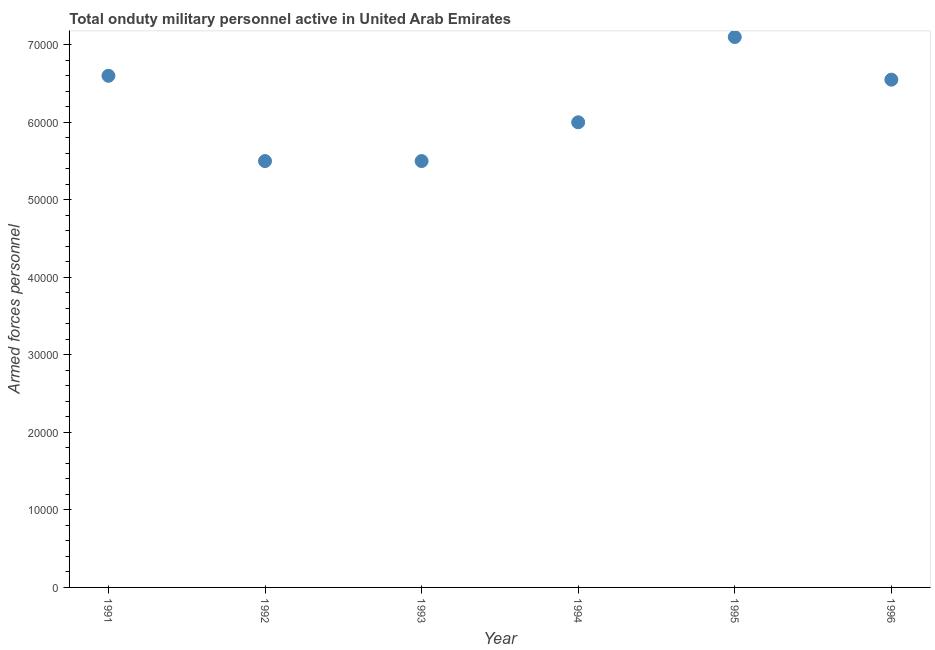What is the number of armed forces personnel in 1993?
Your response must be concise. 5.50e+04. Across all years, what is the maximum number of armed forces personnel?
Keep it short and to the point. 7.10e+04. Across all years, what is the minimum number of armed forces personnel?
Give a very brief answer. 5.50e+04. In which year was the number of armed forces personnel maximum?
Your answer should be very brief. 1995. What is the sum of the number of armed forces personnel?
Give a very brief answer. 3.72e+05. What is the difference between the number of armed forces personnel in 1993 and 1996?
Ensure brevity in your answer.  -1.05e+04. What is the average number of armed forces personnel per year?
Your answer should be very brief. 6.21e+04. What is the median number of armed forces personnel?
Provide a short and direct response. 6.28e+04. Do a majority of the years between 1993 and 1994 (inclusive) have number of armed forces personnel greater than 32000 ?
Provide a succinct answer. Yes. What is the ratio of the number of armed forces personnel in 1993 to that in 1996?
Offer a very short reply. 0.84. Is the difference between the number of armed forces personnel in 1993 and 1995 greater than the difference between any two years?
Offer a terse response. Yes. What is the difference between the highest and the second highest number of armed forces personnel?
Provide a short and direct response. 5000. What is the difference between the highest and the lowest number of armed forces personnel?
Your answer should be compact. 1.60e+04. How many dotlines are there?
Offer a terse response. 1. How many years are there in the graph?
Your answer should be compact. 6. Does the graph contain any zero values?
Make the answer very short. No. What is the title of the graph?
Provide a short and direct response. Total onduty military personnel active in United Arab Emirates. What is the label or title of the X-axis?
Your answer should be very brief. Year. What is the label or title of the Y-axis?
Offer a very short reply. Armed forces personnel. What is the Armed forces personnel in 1991?
Ensure brevity in your answer.  6.60e+04. What is the Armed forces personnel in 1992?
Your answer should be very brief. 5.50e+04. What is the Armed forces personnel in 1993?
Ensure brevity in your answer.  5.50e+04. What is the Armed forces personnel in 1994?
Your answer should be compact. 6.00e+04. What is the Armed forces personnel in 1995?
Make the answer very short. 7.10e+04. What is the Armed forces personnel in 1996?
Offer a terse response. 6.55e+04. What is the difference between the Armed forces personnel in 1991 and 1992?
Ensure brevity in your answer.  1.10e+04. What is the difference between the Armed forces personnel in 1991 and 1993?
Your response must be concise. 1.10e+04. What is the difference between the Armed forces personnel in 1991 and 1994?
Give a very brief answer. 6000. What is the difference between the Armed forces personnel in 1991 and 1995?
Your answer should be compact. -5000. What is the difference between the Armed forces personnel in 1992 and 1994?
Your answer should be compact. -5000. What is the difference between the Armed forces personnel in 1992 and 1995?
Make the answer very short. -1.60e+04. What is the difference between the Armed forces personnel in 1992 and 1996?
Provide a succinct answer. -1.05e+04. What is the difference between the Armed forces personnel in 1993 and 1994?
Your response must be concise. -5000. What is the difference between the Armed forces personnel in 1993 and 1995?
Make the answer very short. -1.60e+04. What is the difference between the Armed forces personnel in 1993 and 1996?
Your response must be concise. -1.05e+04. What is the difference between the Armed forces personnel in 1994 and 1995?
Give a very brief answer. -1.10e+04. What is the difference between the Armed forces personnel in 1994 and 1996?
Make the answer very short. -5500. What is the difference between the Armed forces personnel in 1995 and 1996?
Make the answer very short. 5500. What is the ratio of the Armed forces personnel in 1991 to that in 1993?
Provide a succinct answer. 1.2. What is the ratio of the Armed forces personnel in 1991 to that in 1994?
Offer a very short reply. 1.1. What is the ratio of the Armed forces personnel in 1991 to that in 1995?
Ensure brevity in your answer.  0.93. What is the ratio of the Armed forces personnel in 1991 to that in 1996?
Make the answer very short. 1.01. What is the ratio of the Armed forces personnel in 1992 to that in 1993?
Offer a terse response. 1. What is the ratio of the Armed forces personnel in 1992 to that in 1994?
Ensure brevity in your answer.  0.92. What is the ratio of the Armed forces personnel in 1992 to that in 1995?
Your response must be concise. 0.78. What is the ratio of the Armed forces personnel in 1992 to that in 1996?
Keep it short and to the point. 0.84. What is the ratio of the Armed forces personnel in 1993 to that in 1994?
Your answer should be very brief. 0.92. What is the ratio of the Armed forces personnel in 1993 to that in 1995?
Keep it short and to the point. 0.78. What is the ratio of the Armed forces personnel in 1993 to that in 1996?
Keep it short and to the point. 0.84. What is the ratio of the Armed forces personnel in 1994 to that in 1995?
Make the answer very short. 0.84. What is the ratio of the Armed forces personnel in 1994 to that in 1996?
Keep it short and to the point. 0.92. What is the ratio of the Armed forces personnel in 1995 to that in 1996?
Your answer should be very brief. 1.08. 